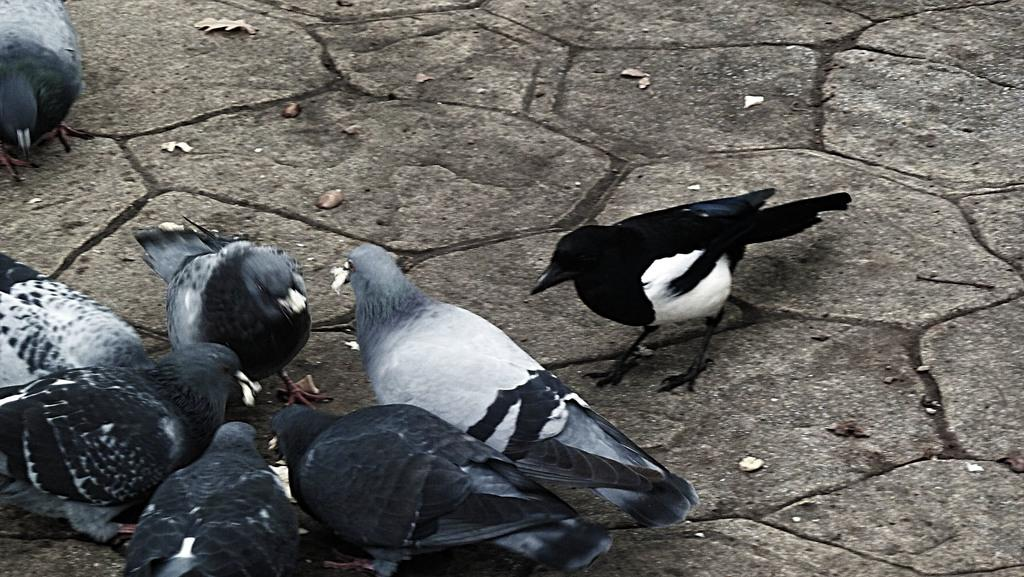What type of birds are in the foreground of the picture? There are pigeons and a black bird in the foreground of the picture. Can you describe the location of the birds in the picture? The pigeons and the black bird are in the foreground of the picture. What type of grain is being harvested by the farmer in the picture? There is no farmer or grain present in the picture; it only features pigeons and a black bird. 